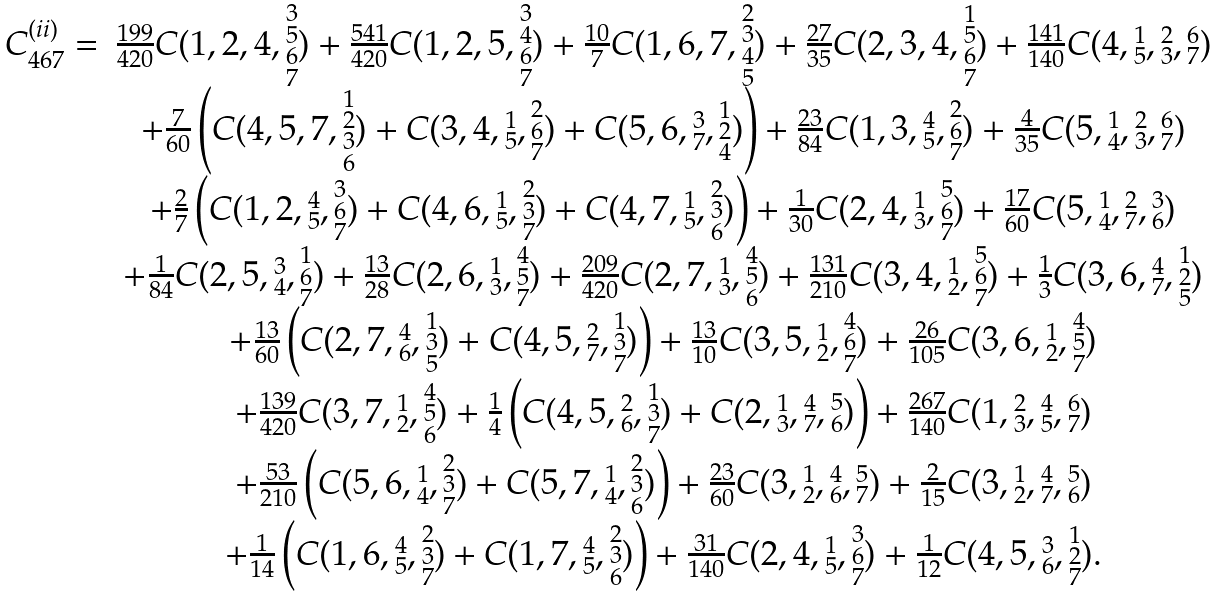Convert formula to latex. <formula><loc_0><loc_0><loc_500><loc_500>\begin{array} { r c } C ^ { ( i i ) } _ { 4 6 7 } = & \frac { 1 9 9 } { 4 2 0 } C ( 1 , 2 , 4 , \substack { 3 \\ 5 \\ 6 \\ 7 } ) + \frac { 5 4 1 } { 4 2 0 } C ( 1 , 2 , 5 , \substack { 3 \\ 4 \\ 6 \\ 7 } ) + \frac { 1 0 } { 7 } C ( 1 , 6 , 7 , \substack { 2 \\ 3 \\ 4 \\ 5 } ) + \frac { 2 7 } { 3 5 } C ( 2 , 3 , 4 , \substack { 1 \\ 5 \\ 6 \\ 7 } ) + \frac { 1 4 1 } { 1 4 0 } C ( 4 , \substack { 1 \\ 5 } , \substack { 2 \\ 3 } , \substack { 6 \\ 7 } ) \\ & + \frac { 7 } { 6 0 } \left ( C ( 4 , 5 , 7 , \substack { 1 \\ 2 \\ 3 \\ 6 } ) + C ( 3 , 4 , \substack { 1 \\ 5 } , \substack { 2 \\ 6 \\ 7 } ) + C ( 5 , 6 , \substack { 3 \\ 7 } , \substack { 1 \\ 2 \\ 4 } ) \right ) + \frac { 2 3 } { 8 4 } C ( 1 , 3 , \substack { 4 \\ 5 } , \substack { 2 \\ 6 \\ 7 } ) + \frac { 4 } { 3 5 } C ( 5 , \substack { 1 \\ 4 } , \substack { 2 \\ 3 } , \substack { 6 \\ 7 } ) \\ & + \frac { 2 } { 7 } \left ( C ( 1 , 2 , \substack { 4 \\ 5 } , \substack { 3 \\ 6 \\ 7 } ) + C ( 4 , 6 , \substack { 1 \\ 5 } , \substack { 2 \\ 3 \\ 7 } ) + C ( 4 , 7 , \substack { 1 \\ 5 } , \substack { 2 \\ 3 \\ 6 } ) \right ) + \frac { 1 } { 3 0 } C ( 2 , 4 , \substack { 1 \\ 3 } , \substack { 5 \\ 6 \\ 7 } ) + \frac { 1 7 } { 6 0 } C ( 5 , \substack { 1 \\ 4 } , \substack { 2 \\ 7 } , \substack { 3 \\ 6 } ) \\ & + \frac { 1 } { 8 4 } C ( 2 , 5 , \substack { 3 \\ 4 } , \substack { 1 \\ 6 \\ 7 } ) + \frac { 1 3 } { 2 8 } C ( 2 , 6 , \substack { 1 \\ 3 } , \substack { 4 \\ 5 \\ 7 } ) + \frac { 2 0 9 } { 4 2 0 } C ( 2 , 7 , \substack { 1 \\ 3 } , \substack { 4 \\ 5 \\ 6 } ) + \frac { 1 3 1 } { 2 1 0 } C ( 3 , 4 , \substack { 1 \\ 2 } , \substack { 5 \\ 6 \\ 7 } ) + \frac { 1 } { 3 } C ( 3 , 6 , \substack { 4 \\ 7 } , \substack { 1 \\ 2 \\ 5 } ) \\ & + \frac { 1 3 } { 6 0 } \left ( C ( 2 , 7 , \substack { 4 \\ 6 } , \substack { 1 \\ 3 \\ 5 } ) + C ( 4 , 5 , \substack { 2 \\ 7 } , \substack { 1 \\ 3 \\ 7 } ) \right ) + \frac { 1 3 } { 1 0 } C ( 3 , 5 , \substack { 1 \\ 2 } , \substack { 4 \\ 6 \\ 7 } ) + \frac { 2 6 } { 1 0 5 } C ( 3 , 6 , \substack { 1 \\ 2 } , \substack { 4 \\ 5 \\ 7 } ) \\ & + \frac { 1 3 9 } { 4 2 0 } C ( 3 , 7 , \substack { 1 \\ 2 } , \substack { 4 \\ 5 \\ 6 } ) + \frac { 1 } { 4 } \left ( C ( 4 , 5 , \substack { 2 \\ 6 } , \substack { 1 \\ 3 \\ 7 } ) + C ( 2 , \substack { 1 \\ 3 } , \substack { 4 \\ 7 } , \substack { 5 \\ 6 } ) \right ) + \frac { 2 6 7 } { 1 4 0 } C ( 1 , \substack { 2 \\ 3 } , \substack { 4 \\ 5 } , \substack { 6 \\ 7 } ) \\ & + \frac { 5 3 } { 2 1 0 } \left ( C ( 5 , 6 , \substack { 1 \\ 4 } , \substack { 2 \\ 3 \\ 7 } ) + C ( 5 , 7 , \substack { 1 \\ 4 } , \substack { 2 \\ 3 \\ 6 } ) \right ) + \frac { 2 3 } { 6 0 } C ( 3 , \substack { 1 \\ 2 } , \substack { 4 \\ 6 } , \substack { 5 \\ 7 } ) + \frac { 2 } { 1 5 } C ( 3 , \substack { 1 \\ 2 } , \substack { 4 \\ 7 } , \substack { 5 \\ 6 } ) \\ & + \frac { 1 } { 1 4 } \left ( C ( 1 , 6 , \substack { 4 \\ 5 } , \substack { 2 \\ 3 \\ 7 } ) + C ( 1 , 7 , \substack { 4 \\ 5 } , \substack { 2 \\ 3 \\ 6 } ) \right ) + \frac { 3 1 } { 1 4 0 } C ( 2 , 4 , \substack { 1 \\ 5 } , \substack { 3 \\ 6 \\ 7 } ) + \frac { 1 } { 1 2 } C ( 4 , 5 , \substack { 3 \\ 6 } , \substack { 1 \\ 2 \\ 7 } ) . \end{array}</formula> 